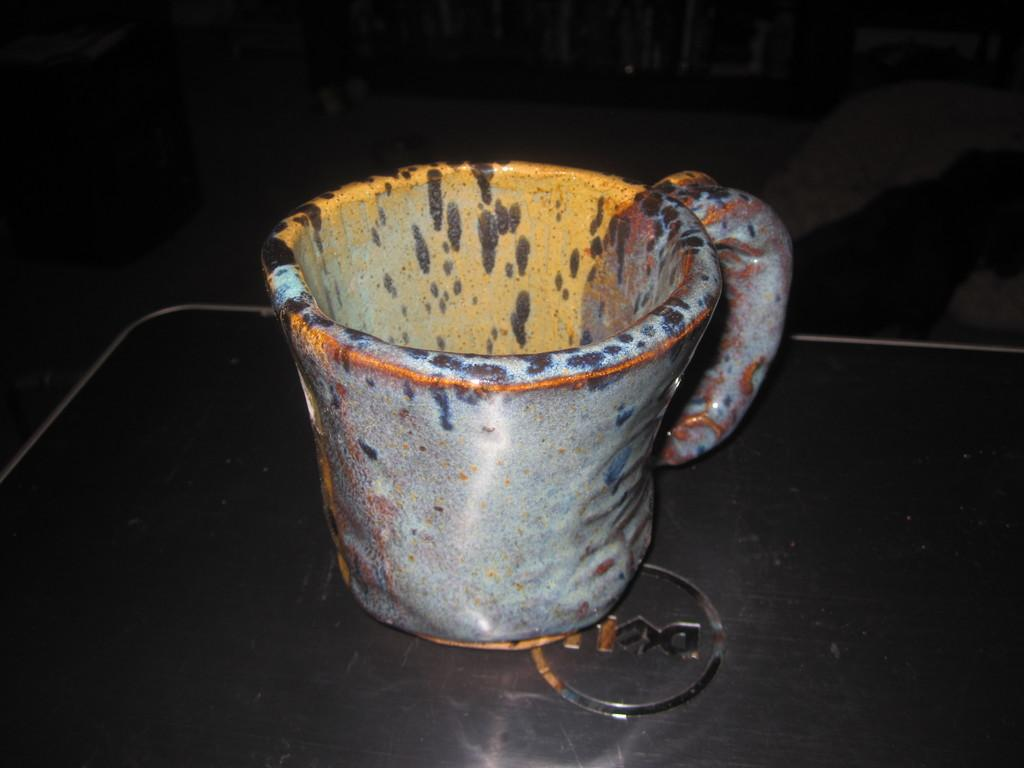What type of object is in the image? There is a colorful cup in the image. What is the cup resting on? The cup is on a black object. How would you describe the overall appearance of the image? The background of the image is dark. What type of action is the hole performing in the image? There is no hole present in the image, so it cannot perform any action. 